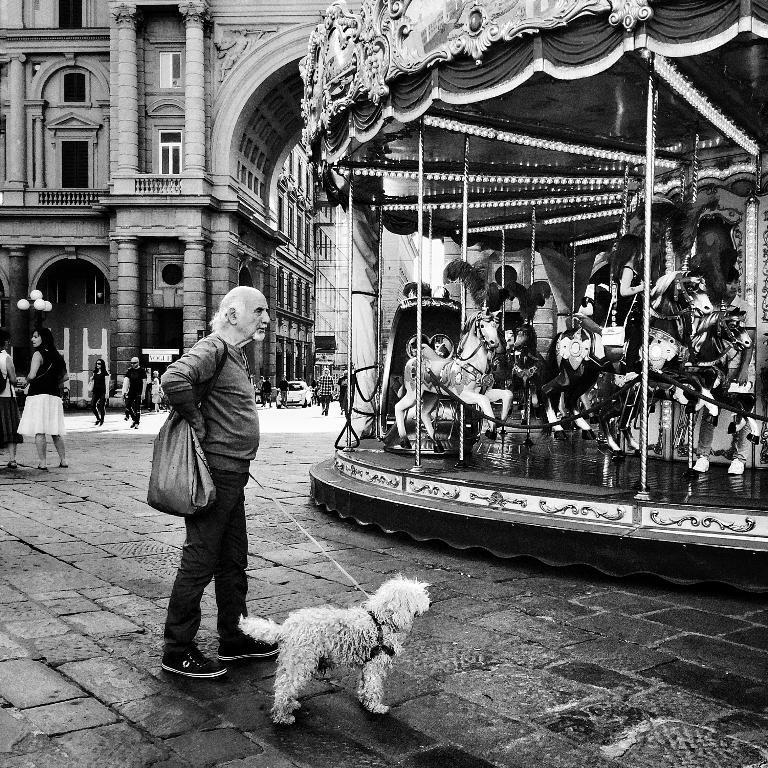In one or two sentences, can you explain what this image depicts? In this image I see a man who is on footpath and he is holding the rope which is tied to a dog, I can also see there are horse ride and few people over here. In the background I see lot of people, a car and the building. 